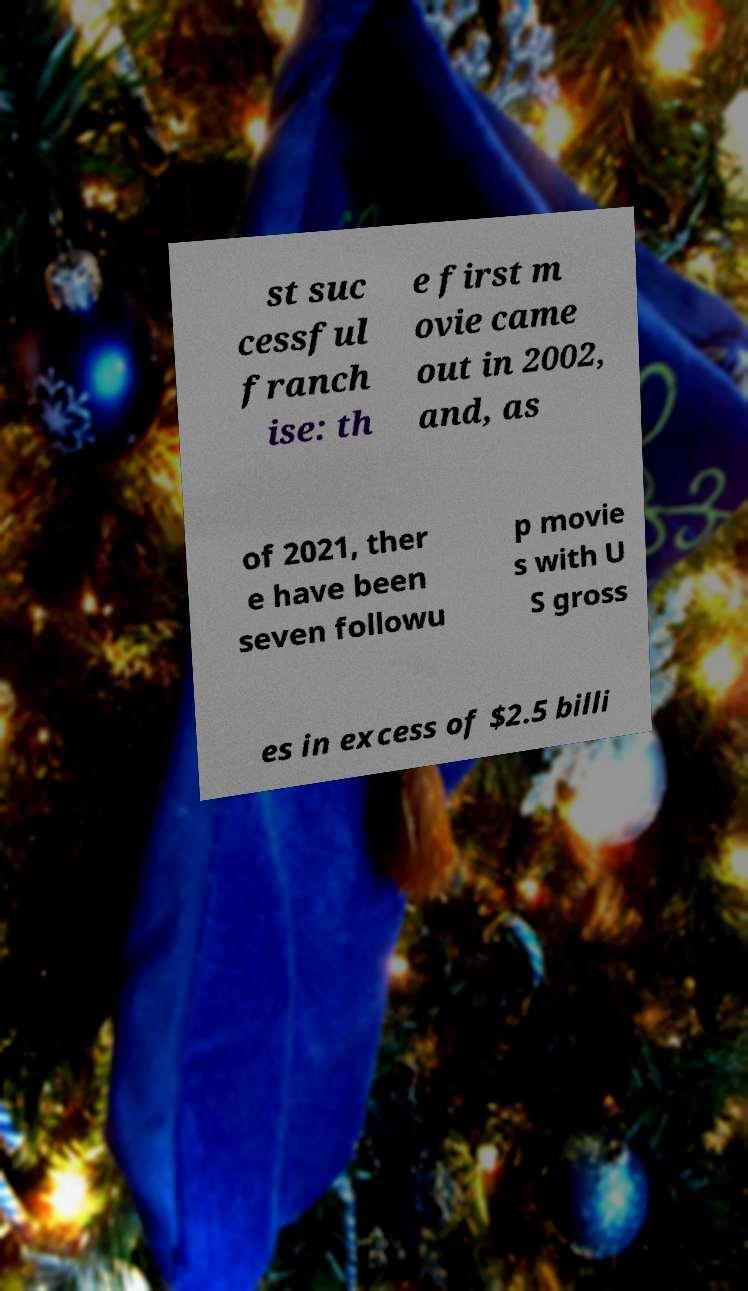Can you read and provide the text displayed in the image?This photo seems to have some interesting text. Can you extract and type it out for me? st suc cessful franch ise: th e first m ovie came out in 2002, and, as of 2021, ther e have been seven followu p movie s with U S gross es in excess of $2.5 billi 